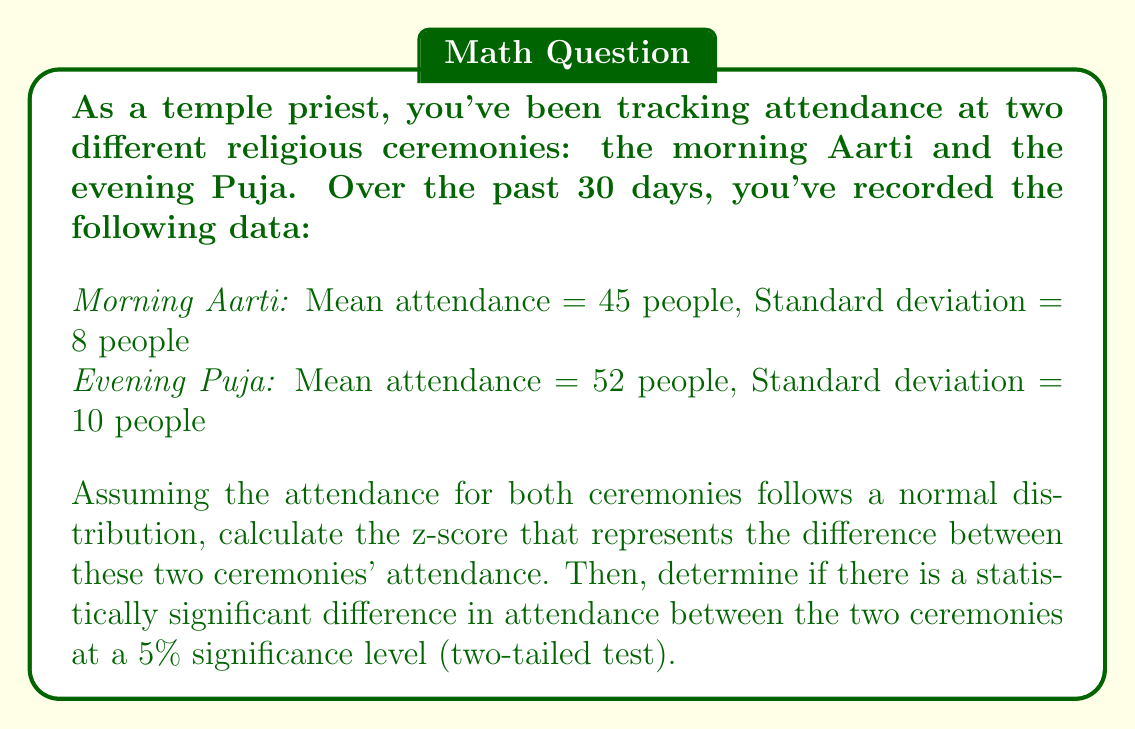Give your solution to this math problem. To solve this problem, we'll follow these steps:

1) First, we need to calculate the standard error of the difference between the two means. The formula for this is:

   $$SE = \sqrt{\frac{s_1^2}{n_1} + \frac{s_2^2}{n_2}}$$

   Where $s_1$ and $s_2$ are the standard deviations, and $n_1$ and $n_2$ are the sample sizes.

2) In this case, both samples are over 30 days, so $n_1 = n_2 = 30$. Let's calculate the standard error:

   $$SE = \sqrt{\frac{8^2}{30} + \frac{10^2}{30}} = \sqrt{\frac{64}{30} + \frac{100}{30}} = \sqrt{\frac{164}{30}} \approx 2.34$$

3) Now, we can calculate the z-score using the formula:

   $$z = \frac{\bar{x_2} - \bar{x_1}}{SE}$$

   Where $\bar{x_2}$ is the mean of the Evening Puja and $\bar{x_1}$ is the mean of the Morning Aarti.

4) Plugging in our values:

   $$z = \frac{52 - 45}{2.34} \approx 2.99$$

5) To determine if this difference is statistically significant at the 5% level (two-tailed test), we need to compare our z-score to the critical value. For a 5% significance level (α = 0.05) in a two-tailed test, the critical z-value is approximately ±1.96.

6) Since our calculated z-score (2.99) is greater than 1.96, we can conclude that there is a statistically significant difference in attendance between the two ceremonies at the 5% significance level.
Answer: The z-score is approximately 2.99. Since 2.99 > 1.96 (the critical value for a 5% significance level in a two-tailed test), there is a statistically significant difference in attendance between the morning Aarti and evening Puja ceremonies. 